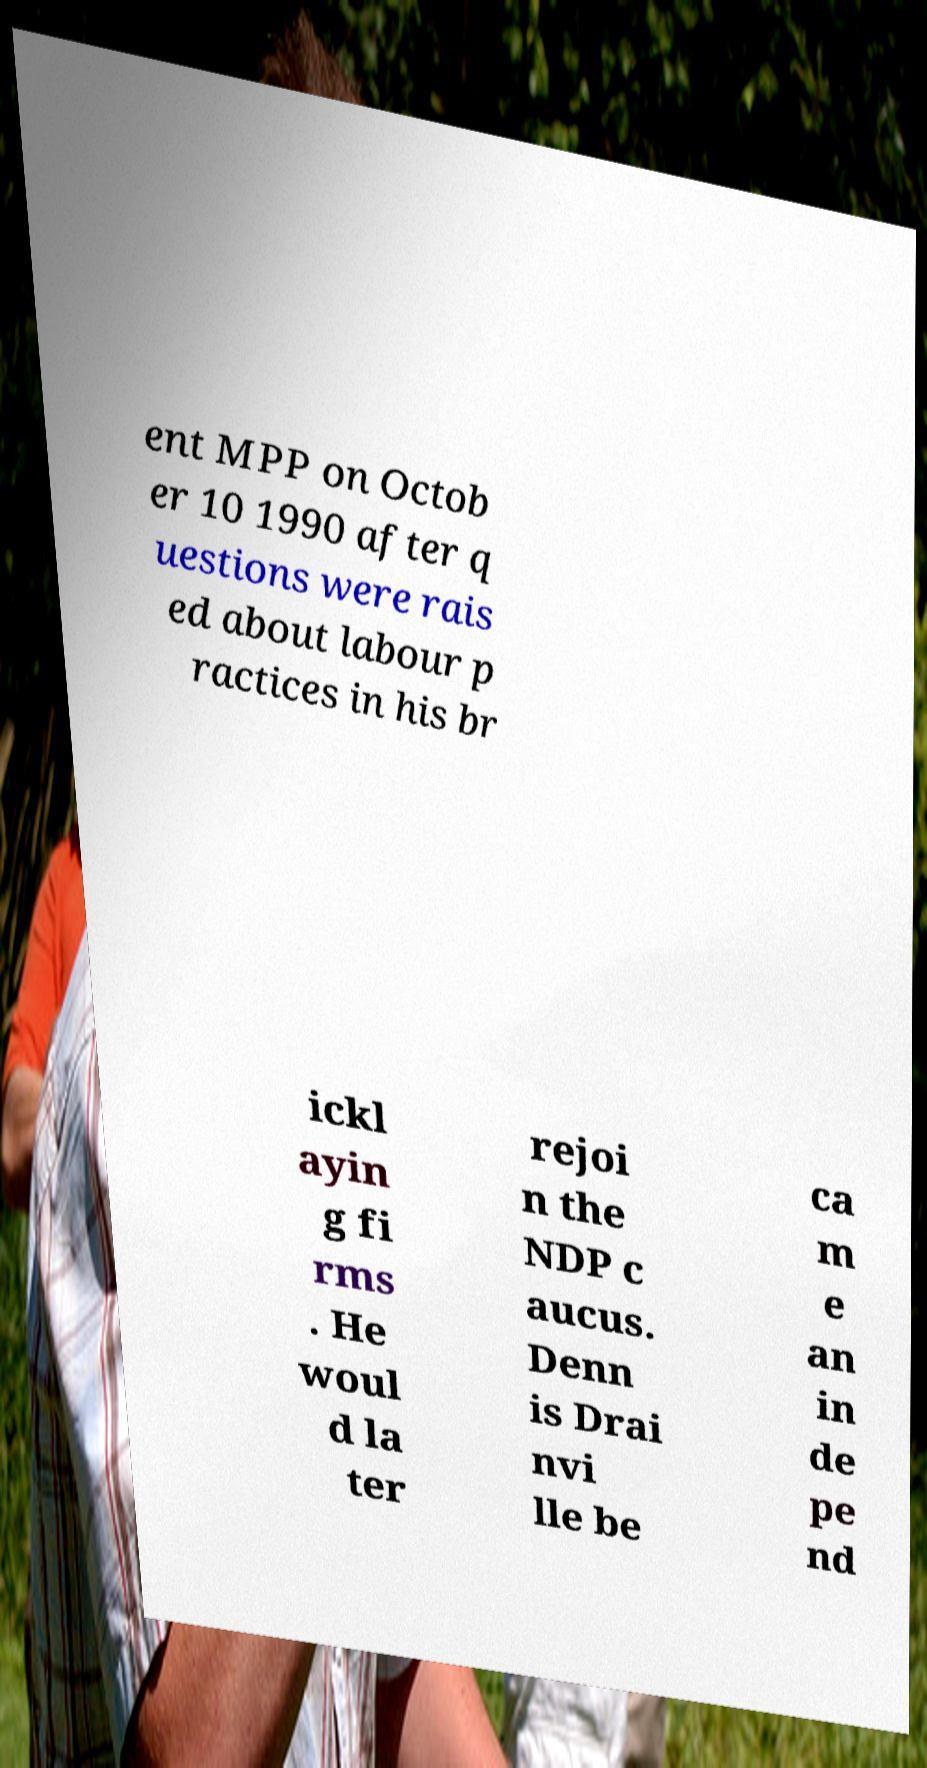Can you accurately transcribe the text from the provided image for me? ent MPP on Octob er 10 1990 after q uestions were rais ed about labour p ractices in his br ickl ayin g fi rms . He woul d la ter rejoi n the NDP c aucus. Denn is Drai nvi lle be ca m e an in de pe nd 